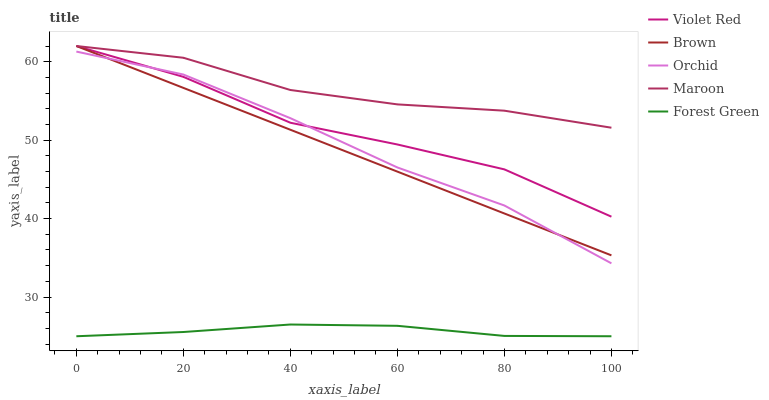Does Forest Green have the minimum area under the curve?
Answer yes or no. Yes. Does Maroon have the maximum area under the curve?
Answer yes or no. Yes. Does Violet Red have the minimum area under the curve?
Answer yes or no. No. Does Violet Red have the maximum area under the curve?
Answer yes or no. No. Is Brown the smoothest?
Answer yes or no. Yes. Is Violet Red the roughest?
Answer yes or no. Yes. Is Forest Green the smoothest?
Answer yes or no. No. Is Forest Green the roughest?
Answer yes or no. No. Does Forest Green have the lowest value?
Answer yes or no. Yes. Does Violet Red have the lowest value?
Answer yes or no. No. Does Maroon have the highest value?
Answer yes or no. Yes. Does Forest Green have the highest value?
Answer yes or no. No. Is Forest Green less than Brown?
Answer yes or no. Yes. Is Orchid greater than Forest Green?
Answer yes or no. Yes. Does Maroon intersect Violet Red?
Answer yes or no. Yes. Is Maroon less than Violet Red?
Answer yes or no. No. Is Maroon greater than Violet Red?
Answer yes or no. No. Does Forest Green intersect Brown?
Answer yes or no. No. 